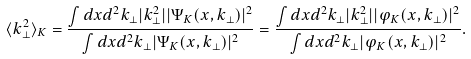Convert formula to latex. <formula><loc_0><loc_0><loc_500><loc_500>\langle k _ { \perp } ^ { 2 } \rangle _ { K } = \frac { \int d x d ^ { 2 } k _ { \perp } | k _ { \perp } ^ { 2 } | | \Psi _ { K } ( x , { k } _ { \perp } ) | ^ { 2 } } { \int d x d ^ { 2 } k _ { \perp } | \Psi _ { K } ( x , { k } _ { \perp } ) | ^ { 2 } } = \frac { \int d x d ^ { 2 } k _ { \perp } | k _ { \perp } ^ { 2 } | | \varphi _ { K } ( x , { k } _ { \perp } ) | ^ { 2 } } { \int d x d ^ { 2 } k _ { \perp } | \varphi _ { K } ( x , { k } _ { \perp } ) | ^ { 2 } } .</formula> 